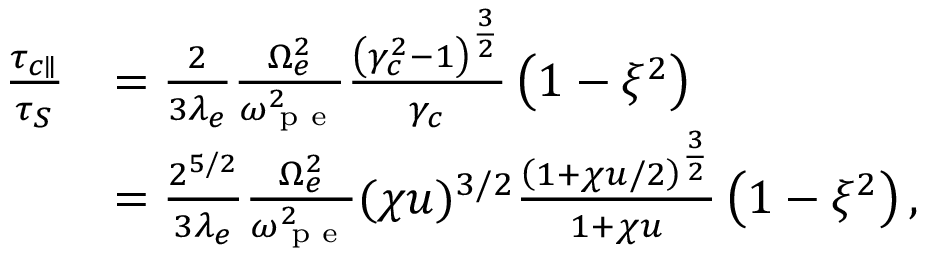Convert formula to latex. <formula><loc_0><loc_0><loc_500><loc_500>\begin{array} { r l } { \frac { \tau _ { c \| } } { \tau _ { S } } } & { = \frac { 2 } { 3 \lambda _ { e } } \frac { \Omega _ { e } ^ { 2 } } { \omega _ { p e } ^ { 2 } } \frac { \left ( \gamma _ { c } ^ { 2 } - 1 \right ) ^ { \frac { 3 } { 2 } } } { \gamma _ { c } } \left ( 1 - \xi ^ { 2 } \right ) } \\ & { = \frac { 2 ^ { 5 / 2 } } { 3 \lambda _ { e } } \frac { \Omega _ { e } ^ { 2 } } { \omega _ { p e } ^ { 2 } } ( \chi u ) ^ { 3 / 2 } \frac { \left ( 1 + \chi u / 2 \right ) ^ { \frac { 3 } { 2 } } } { 1 + \chi u } \left ( 1 - \xi ^ { 2 } \right ) , } \end{array}</formula> 